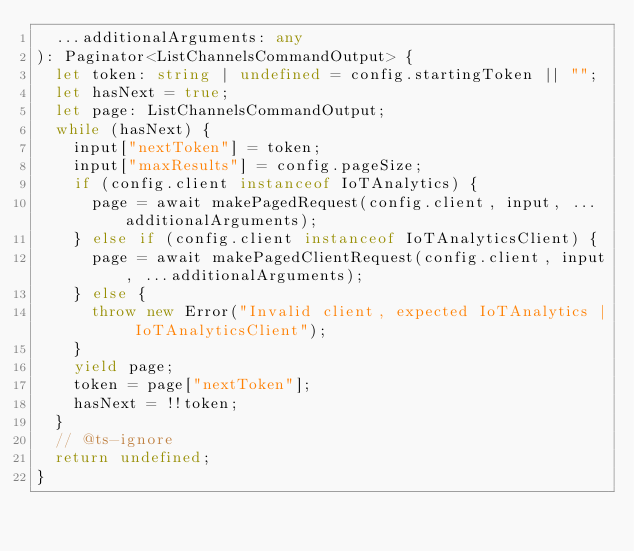Convert code to text. <code><loc_0><loc_0><loc_500><loc_500><_TypeScript_>  ...additionalArguments: any
): Paginator<ListChannelsCommandOutput> {
  let token: string | undefined = config.startingToken || "";
  let hasNext = true;
  let page: ListChannelsCommandOutput;
  while (hasNext) {
    input["nextToken"] = token;
    input["maxResults"] = config.pageSize;
    if (config.client instanceof IoTAnalytics) {
      page = await makePagedRequest(config.client, input, ...additionalArguments);
    } else if (config.client instanceof IoTAnalyticsClient) {
      page = await makePagedClientRequest(config.client, input, ...additionalArguments);
    } else {
      throw new Error("Invalid client, expected IoTAnalytics | IoTAnalyticsClient");
    }
    yield page;
    token = page["nextToken"];
    hasNext = !!token;
  }
  // @ts-ignore
  return undefined;
}
</code> 